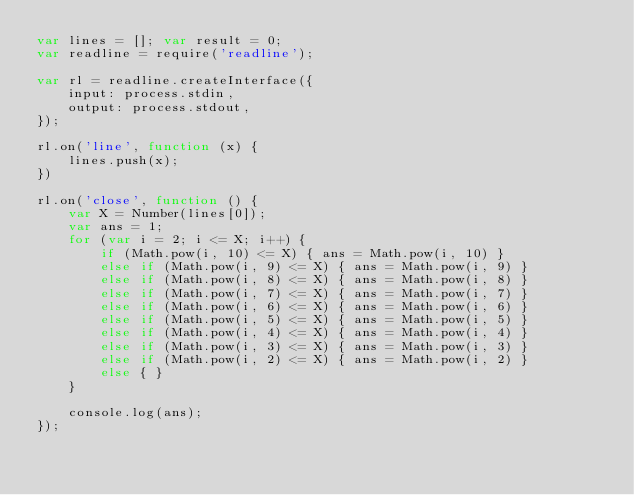Convert code to text. <code><loc_0><loc_0><loc_500><loc_500><_JavaScript_>var lines = []; var result = 0;
var readline = require('readline');

var rl = readline.createInterface({
    input: process.stdin,
    output: process.stdout,
});

rl.on('line', function (x) {
    lines.push(x);
})

rl.on('close', function () {
    var X = Number(lines[0]);
    var ans = 1;
    for (var i = 2; i <= X; i++) {
        if (Math.pow(i, 10) <= X) { ans = Math.pow(i, 10) }
        else if (Math.pow(i, 9) <= X) { ans = Math.pow(i, 9) }
        else if (Math.pow(i, 8) <= X) { ans = Math.pow(i, 8) }
        else if (Math.pow(i, 7) <= X) { ans = Math.pow(i, 7) }
        else if (Math.pow(i, 6) <= X) { ans = Math.pow(i, 6) }
        else if (Math.pow(i, 5) <= X) { ans = Math.pow(i, 5) }
        else if (Math.pow(i, 4) <= X) { ans = Math.pow(i, 4) }
        else if (Math.pow(i, 3) <= X) { ans = Math.pow(i, 3) }
        else if (Math.pow(i, 2) <= X) { ans = Math.pow(i, 2) }
        else { }
    }

    console.log(ans);
});</code> 